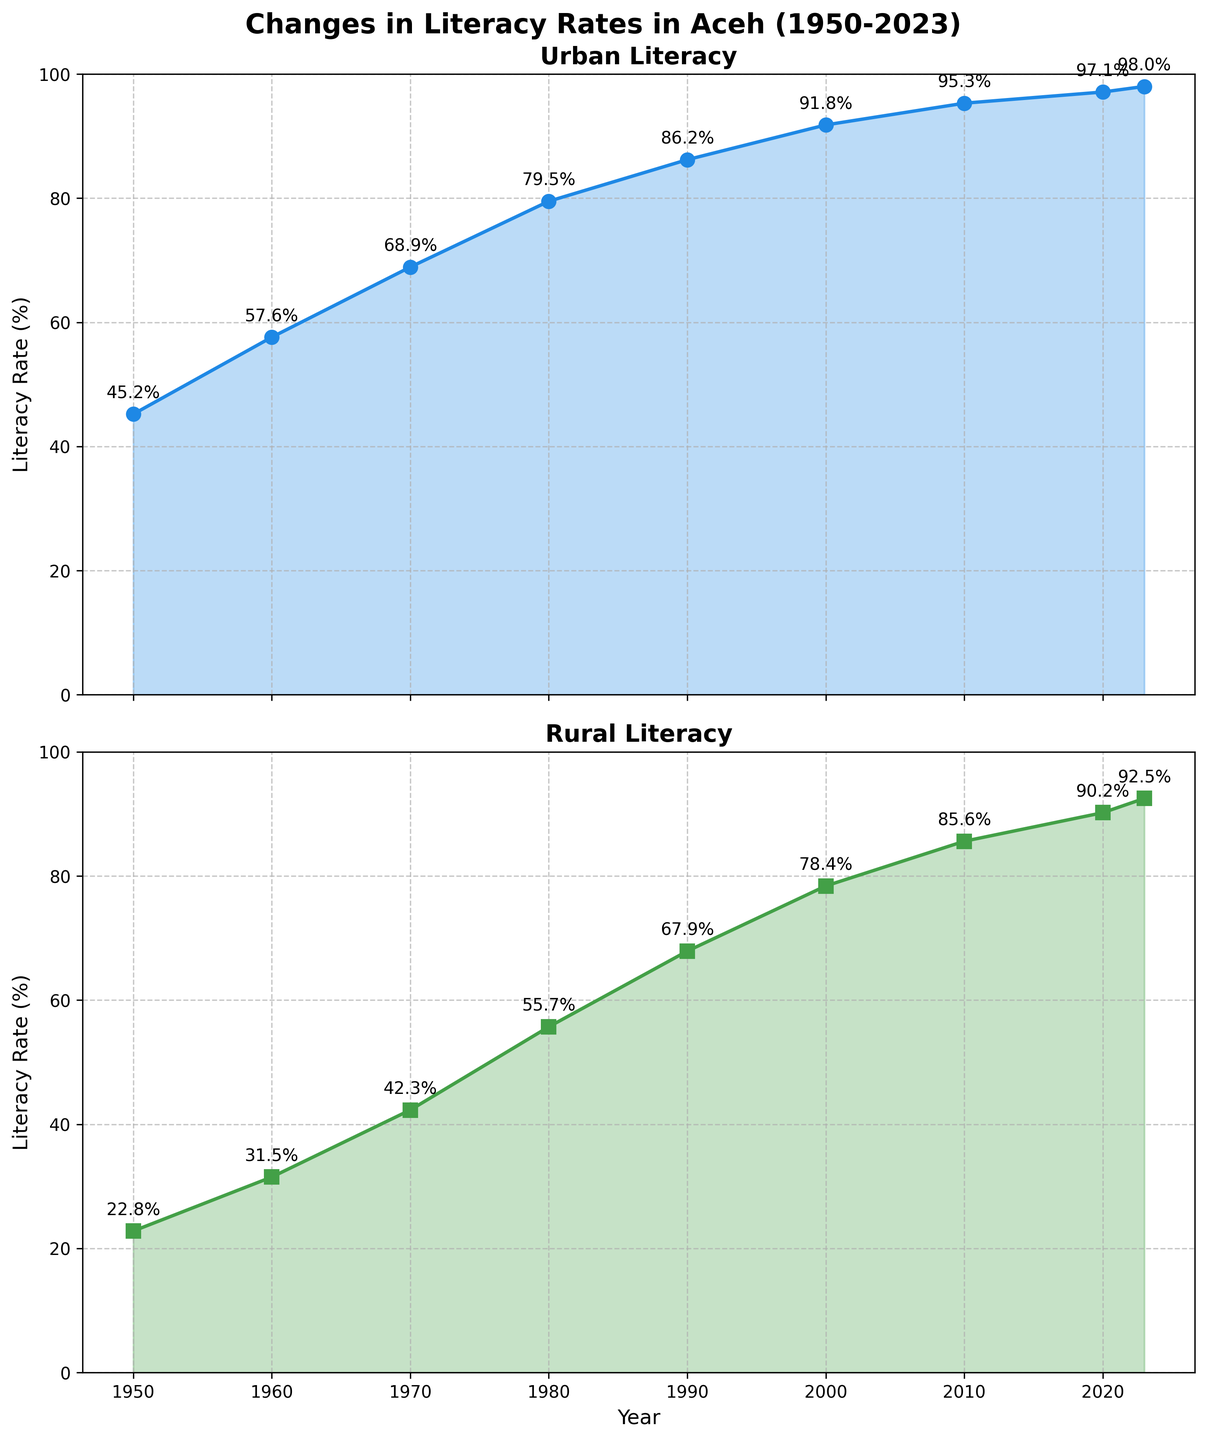What is the title of the figure? The title of the figure is located at the top of the figure and is usually written in a larger and bolder font.
Answer: Changes in Literacy Rates in Aceh (1950-2023) How many subplots are there in the figure? By observing the layout of the figure, it can be seen that there are two separate graphs or subplots.
Answer: 2 What are the y-axis labels in the subplots? To find the y-axis labels, look along the vertical axes of both subplots. The same label is used for both subplots.
Answer: Literacy Rate (%) Which year has the largest difference between urban and rural literacy rates? To answer this, observe the values for urban and rural literacy for each year and calculate the difference. The year with the largest difference will be the one with the maximum gap. In 1950, the rates are 45.2% and 22.8%, with a difference of 22.4%.
Answer: 1950 What color is used for the urban literacy line? The color of the urban literacy line is found by observing the urban subplot. The line color is blue.
Answer: Blue Which year had the lowest rural literacy rate? By examining the values on the rural literacy subplot, the lowest rural literacy rate is found in 1950.
Answer: 1950 What is the overall trend in urban literacy rates from 1950 to 2023? To determine the trend, observe how the urban literacy rates change over the years. The rates increase consistently from 1950 to 2023.
Answer: Increasing What was the urban literacy rate in 1980? Locate the year 1980 on the x-axis of the urban subplot and find the corresponding y-axis value. The urban literacy rate is 79.5%.
Answer: 79.5% In which decade did the rural literacy rate first exceed 50%? To answer this, identify the year when the rural literacy rate surpassed 50% by looking at the rural literacy plot. This happened in the 1970s, specifically in 1980.
Answer: 1980 What are the literacy rates for urban and rural areas in 2023? For this, refer to the endpoints of both subplots for the year 2023. The urban literacy rate is 98.0%, and the rural literacy rate is 92.5%.
Answer: Urban: 98.0%, Rural: 92.5% 